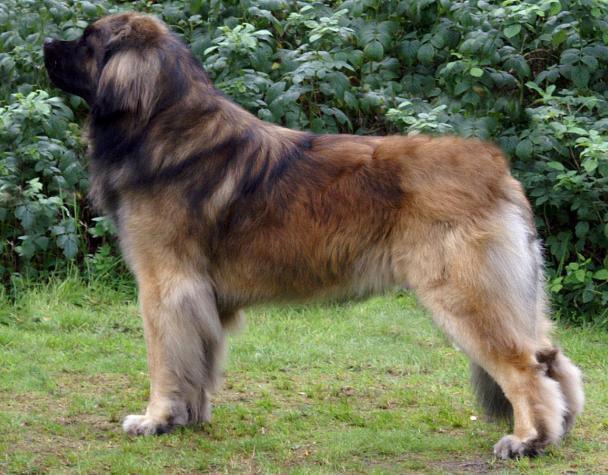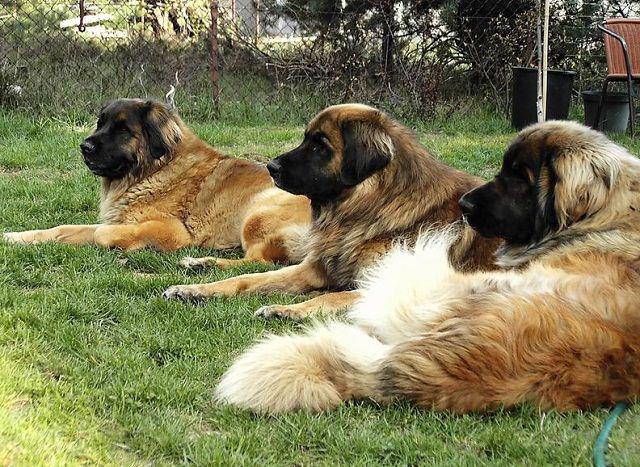The first image is the image on the left, the second image is the image on the right. Assess this claim about the two images: "In one of the images there are at least three large dogs laying on the ground next to each other.". Correct or not? Answer yes or no. Yes. 